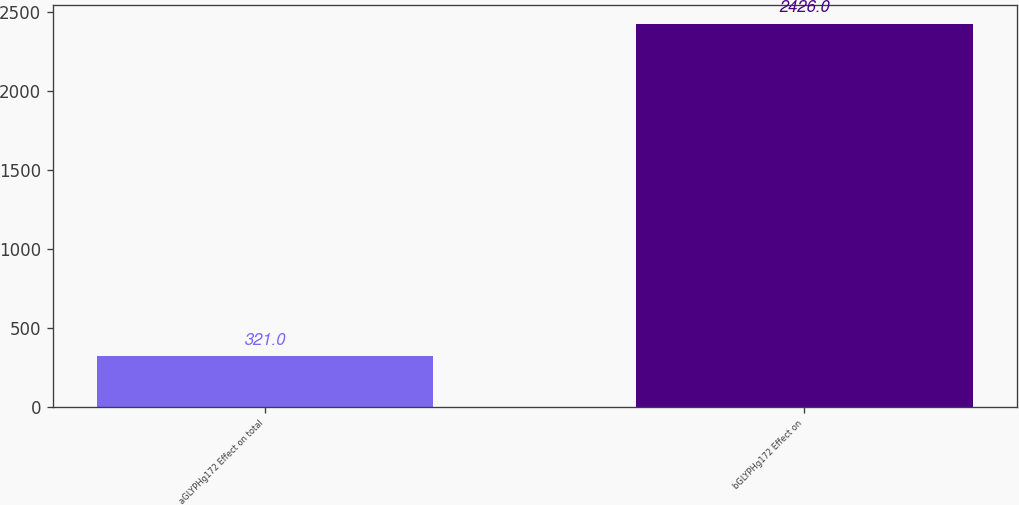<chart> <loc_0><loc_0><loc_500><loc_500><bar_chart><fcel>aGLYPHg172 Effect on total<fcel>bGLYPHg172 Effect on<nl><fcel>321<fcel>2426<nl></chart> 